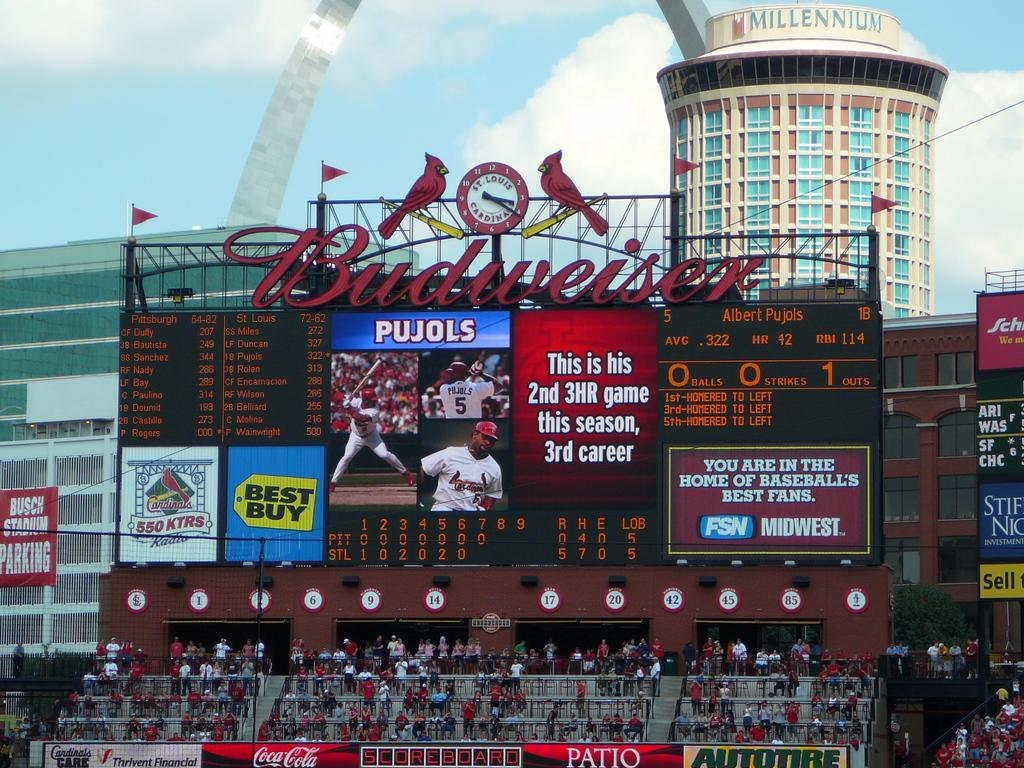<image>
Render a clear and concise summary of the photo. A stadium sponsored by Budweiser and Best Buy. 